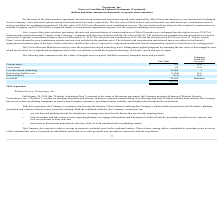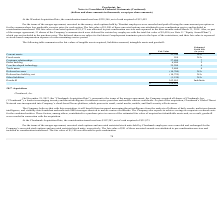According to Proofpoint's financial document, In what aspects is Proofpoint trying to achieve savings in? corporate overhead costs for the combined entities. The document states: "The Company also expects to achieve savings in corporate overhead costs for the combined entities. These factors, among others, contributed to a purch..." Also, Under what conditions will the deferred shares be subjected to forfeiture? If employment terminates prior to the lapse of the restrictions, and their fair value is expensed as stock-based compensation expense over the remaining service period. The document states: "ce. The deferred shares are subject to forfeiture if employment terminates prior to the lapse of the restrictions, and their fair value is expensed as..." Also, How long is the estimated useful life for the Goodwill? According to the financial document, Indefinite. The relevant text states: "Goodwill 162,865 Indefinite..." Also, can you calculate: What is the difference in estimated fair value between current assets and fixed assets? Based on the calculation: $23,344 - 954, the result is 22390 (in thousands). This is based on the information: "Current assets $ 23,344 N/A Fixed assets 954 N/A..." The key data points involved are: 23,344, 954. Also, can you calculate: What is the average estimated fair value of Customer relationships? Based on the calculation: 37,800 / 7, the result is 5400 (in thousands). This is based on the information: "Customer relationships 37,800 7 Customer relationships 37,800 7..." The key data points involved are: 37,800, 7. Also, can you calculate: What is the total estimated fair value of all assets? Based on the calculation: $23,344 + 954 + 37,800 + 6,800 + 35,200 + 2,400, the result is 106498 (in thousands). This is based on the information: "Trade name 2,400 4 Order backlog 6,800 2 Fixed assets 954 N/A Customer relationships 37,800 7 Current assets $ 23,344 N/A Core/developed technology 35,200 4..." The key data points involved are: 2,400, 23,344, 35,200. 